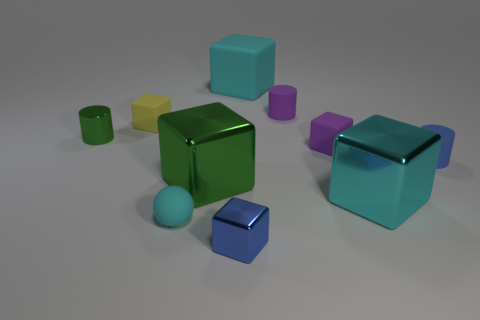Subtract all large green cubes. How many cubes are left? 5 Subtract all blue cylinders. How many cylinders are left? 2 Subtract 1 spheres. How many spheres are left? 0 Subtract all green cylinders. How many cyan blocks are left? 2 Subtract all cylinders. How many objects are left? 7 Subtract all purple rubber cylinders. Subtract all green metal cubes. How many objects are left? 8 Add 1 tiny matte cubes. How many tiny matte cubes are left? 3 Add 4 tiny purple cylinders. How many tiny purple cylinders exist? 5 Subtract 1 cyan spheres. How many objects are left? 9 Subtract all gray spheres. Subtract all yellow cubes. How many spheres are left? 1 